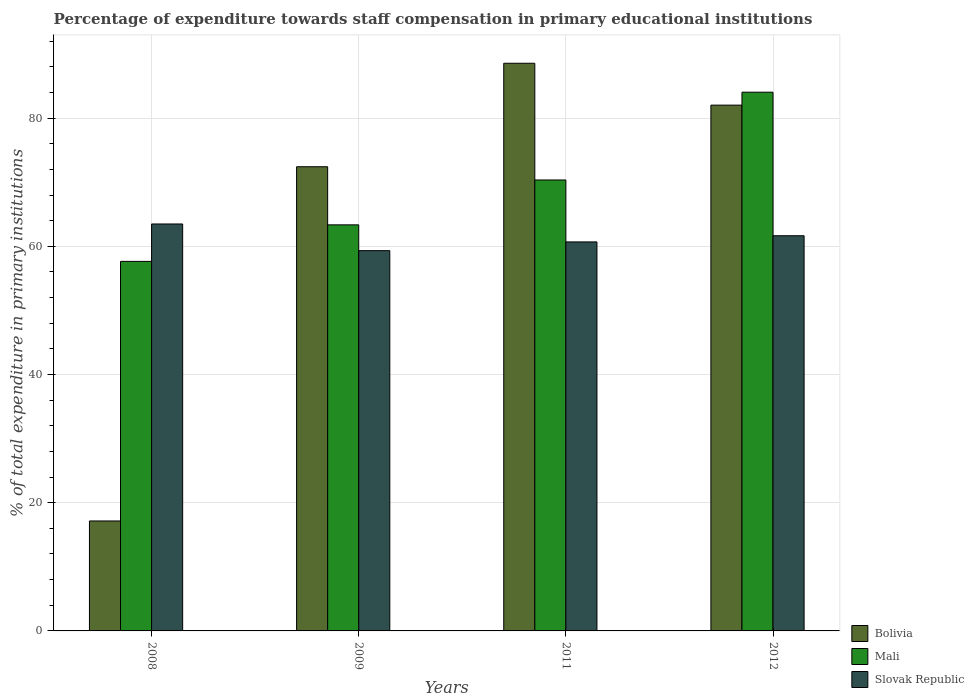How many different coloured bars are there?
Offer a terse response. 3. Are the number of bars per tick equal to the number of legend labels?
Your answer should be very brief. Yes. How many bars are there on the 1st tick from the left?
Keep it short and to the point. 3. What is the label of the 2nd group of bars from the left?
Provide a succinct answer. 2009. In how many cases, is the number of bars for a given year not equal to the number of legend labels?
Ensure brevity in your answer.  0. What is the percentage of expenditure towards staff compensation in Bolivia in 2008?
Your answer should be compact. 17.15. Across all years, what is the maximum percentage of expenditure towards staff compensation in Slovak Republic?
Provide a short and direct response. 63.48. Across all years, what is the minimum percentage of expenditure towards staff compensation in Slovak Republic?
Make the answer very short. 59.32. In which year was the percentage of expenditure towards staff compensation in Mali minimum?
Offer a very short reply. 2008. What is the total percentage of expenditure towards staff compensation in Slovak Republic in the graph?
Keep it short and to the point. 245.14. What is the difference between the percentage of expenditure towards staff compensation in Mali in 2009 and that in 2011?
Make the answer very short. -7. What is the difference between the percentage of expenditure towards staff compensation in Bolivia in 2008 and the percentage of expenditure towards staff compensation in Slovak Republic in 2012?
Keep it short and to the point. -44.49. What is the average percentage of expenditure towards staff compensation in Slovak Republic per year?
Make the answer very short. 61.28. In the year 2009, what is the difference between the percentage of expenditure towards staff compensation in Slovak Republic and percentage of expenditure towards staff compensation in Bolivia?
Provide a succinct answer. -13.09. What is the ratio of the percentage of expenditure towards staff compensation in Mali in 2008 to that in 2012?
Provide a succinct answer. 0.69. Is the percentage of expenditure towards staff compensation in Mali in 2009 less than that in 2012?
Provide a succinct answer. Yes. What is the difference between the highest and the second highest percentage of expenditure towards staff compensation in Bolivia?
Provide a succinct answer. 6.53. What is the difference between the highest and the lowest percentage of expenditure towards staff compensation in Slovak Republic?
Your answer should be very brief. 4.16. Is the sum of the percentage of expenditure towards staff compensation in Slovak Republic in 2009 and 2012 greater than the maximum percentage of expenditure towards staff compensation in Mali across all years?
Keep it short and to the point. Yes. What does the 1st bar from the left in 2008 represents?
Your response must be concise. Bolivia. What does the 3rd bar from the right in 2011 represents?
Ensure brevity in your answer.  Bolivia. How many bars are there?
Your answer should be compact. 12. How many years are there in the graph?
Offer a terse response. 4. Does the graph contain any zero values?
Ensure brevity in your answer.  No. Does the graph contain grids?
Make the answer very short. Yes. How many legend labels are there?
Provide a succinct answer. 3. What is the title of the graph?
Ensure brevity in your answer.  Percentage of expenditure towards staff compensation in primary educational institutions. Does "New Caledonia" appear as one of the legend labels in the graph?
Your answer should be compact. No. What is the label or title of the X-axis?
Provide a short and direct response. Years. What is the label or title of the Y-axis?
Your answer should be compact. % of total expenditure in primary institutions. What is the % of total expenditure in primary institutions of Bolivia in 2008?
Ensure brevity in your answer.  17.15. What is the % of total expenditure in primary institutions in Mali in 2008?
Your answer should be very brief. 57.65. What is the % of total expenditure in primary institutions in Slovak Republic in 2008?
Provide a succinct answer. 63.48. What is the % of total expenditure in primary institutions of Bolivia in 2009?
Give a very brief answer. 72.41. What is the % of total expenditure in primary institutions in Mali in 2009?
Provide a short and direct response. 63.35. What is the % of total expenditure in primary institutions of Slovak Republic in 2009?
Ensure brevity in your answer.  59.32. What is the % of total expenditure in primary institutions of Bolivia in 2011?
Give a very brief answer. 88.55. What is the % of total expenditure in primary institutions of Mali in 2011?
Your answer should be compact. 70.35. What is the % of total expenditure in primary institutions of Slovak Republic in 2011?
Give a very brief answer. 60.68. What is the % of total expenditure in primary institutions of Bolivia in 2012?
Give a very brief answer. 82.02. What is the % of total expenditure in primary institutions of Mali in 2012?
Your answer should be compact. 84.04. What is the % of total expenditure in primary institutions in Slovak Republic in 2012?
Ensure brevity in your answer.  61.65. Across all years, what is the maximum % of total expenditure in primary institutions of Bolivia?
Your answer should be compact. 88.55. Across all years, what is the maximum % of total expenditure in primary institutions of Mali?
Provide a succinct answer. 84.04. Across all years, what is the maximum % of total expenditure in primary institutions of Slovak Republic?
Offer a very short reply. 63.48. Across all years, what is the minimum % of total expenditure in primary institutions in Bolivia?
Keep it short and to the point. 17.15. Across all years, what is the minimum % of total expenditure in primary institutions in Mali?
Offer a very short reply. 57.65. Across all years, what is the minimum % of total expenditure in primary institutions in Slovak Republic?
Provide a short and direct response. 59.32. What is the total % of total expenditure in primary institutions in Bolivia in the graph?
Make the answer very short. 260.14. What is the total % of total expenditure in primary institutions in Mali in the graph?
Offer a very short reply. 275.38. What is the total % of total expenditure in primary institutions in Slovak Republic in the graph?
Make the answer very short. 245.14. What is the difference between the % of total expenditure in primary institutions of Bolivia in 2008 and that in 2009?
Make the answer very short. -55.26. What is the difference between the % of total expenditure in primary institutions of Mali in 2008 and that in 2009?
Your response must be concise. -5.7. What is the difference between the % of total expenditure in primary institutions of Slovak Republic in 2008 and that in 2009?
Your response must be concise. 4.16. What is the difference between the % of total expenditure in primary institutions of Bolivia in 2008 and that in 2011?
Make the answer very short. -71.4. What is the difference between the % of total expenditure in primary institutions of Mali in 2008 and that in 2011?
Provide a succinct answer. -12.7. What is the difference between the % of total expenditure in primary institutions of Slovak Republic in 2008 and that in 2011?
Provide a succinct answer. 2.8. What is the difference between the % of total expenditure in primary institutions of Bolivia in 2008 and that in 2012?
Keep it short and to the point. -64.87. What is the difference between the % of total expenditure in primary institutions in Mali in 2008 and that in 2012?
Offer a terse response. -26.39. What is the difference between the % of total expenditure in primary institutions of Slovak Republic in 2008 and that in 2012?
Provide a short and direct response. 1.83. What is the difference between the % of total expenditure in primary institutions of Bolivia in 2009 and that in 2011?
Your answer should be very brief. -16.14. What is the difference between the % of total expenditure in primary institutions in Mali in 2009 and that in 2011?
Keep it short and to the point. -7. What is the difference between the % of total expenditure in primary institutions in Slovak Republic in 2009 and that in 2011?
Your response must be concise. -1.36. What is the difference between the % of total expenditure in primary institutions of Bolivia in 2009 and that in 2012?
Your answer should be very brief. -9.61. What is the difference between the % of total expenditure in primary institutions in Mali in 2009 and that in 2012?
Give a very brief answer. -20.69. What is the difference between the % of total expenditure in primary institutions of Slovak Republic in 2009 and that in 2012?
Offer a terse response. -2.33. What is the difference between the % of total expenditure in primary institutions of Bolivia in 2011 and that in 2012?
Offer a terse response. 6.53. What is the difference between the % of total expenditure in primary institutions in Mali in 2011 and that in 2012?
Your answer should be compact. -13.69. What is the difference between the % of total expenditure in primary institutions in Slovak Republic in 2011 and that in 2012?
Provide a succinct answer. -0.96. What is the difference between the % of total expenditure in primary institutions of Bolivia in 2008 and the % of total expenditure in primary institutions of Mali in 2009?
Your response must be concise. -46.19. What is the difference between the % of total expenditure in primary institutions in Bolivia in 2008 and the % of total expenditure in primary institutions in Slovak Republic in 2009?
Provide a short and direct response. -42.17. What is the difference between the % of total expenditure in primary institutions in Mali in 2008 and the % of total expenditure in primary institutions in Slovak Republic in 2009?
Your response must be concise. -1.67. What is the difference between the % of total expenditure in primary institutions in Bolivia in 2008 and the % of total expenditure in primary institutions in Mali in 2011?
Offer a very short reply. -53.19. What is the difference between the % of total expenditure in primary institutions of Bolivia in 2008 and the % of total expenditure in primary institutions of Slovak Republic in 2011?
Your response must be concise. -43.53. What is the difference between the % of total expenditure in primary institutions of Mali in 2008 and the % of total expenditure in primary institutions of Slovak Republic in 2011?
Keep it short and to the point. -3.04. What is the difference between the % of total expenditure in primary institutions of Bolivia in 2008 and the % of total expenditure in primary institutions of Mali in 2012?
Provide a succinct answer. -66.89. What is the difference between the % of total expenditure in primary institutions of Bolivia in 2008 and the % of total expenditure in primary institutions of Slovak Republic in 2012?
Provide a short and direct response. -44.49. What is the difference between the % of total expenditure in primary institutions of Mali in 2008 and the % of total expenditure in primary institutions of Slovak Republic in 2012?
Provide a short and direct response. -4. What is the difference between the % of total expenditure in primary institutions of Bolivia in 2009 and the % of total expenditure in primary institutions of Mali in 2011?
Your answer should be very brief. 2.06. What is the difference between the % of total expenditure in primary institutions in Bolivia in 2009 and the % of total expenditure in primary institutions in Slovak Republic in 2011?
Make the answer very short. 11.73. What is the difference between the % of total expenditure in primary institutions of Mali in 2009 and the % of total expenditure in primary institutions of Slovak Republic in 2011?
Your answer should be compact. 2.66. What is the difference between the % of total expenditure in primary institutions of Bolivia in 2009 and the % of total expenditure in primary institutions of Mali in 2012?
Give a very brief answer. -11.63. What is the difference between the % of total expenditure in primary institutions in Bolivia in 2009 and the % of total expenditure in primary institutions in Slovak Republic in 2012?
Your answer should be compact. 10.76. What is the difference between the % of total expenditure in primary institutions in Mali in 2009 and the % of total expenditure in primary institutions in Slovak Republic in 2012?
Your answer should be very brief. 1.7. What is the difference between the % of total expenditure in primary institutions of Bolivia in 2011 and the % of total expenditure in primary institutions of Mali in 2012?
Your response must be concise. 4.51. What is the difference between the % of total expenditure in primary institutions of Bolivia in 2011 and the % of total expenditure in primary institutions of Slovak Republic in 2012?
Your answer should be compact. 26.91. What is the difference between the % of total expenditure in primary institutions in Mali in 2011 and the % of total expenditure in primary institutions in Slovak Republic in 2012?
Offer a very short reply. 8.7. What is the average % of total expenditure in primary institutions of Bolivia per year?
Your answer should be very brief. 65.04. What is the average % of total expenditure in primary institutions in Mali per year?
Your response must be concise. 68.85. What is the average % of total expenditure in primary institutions of Slovak Republic per year?
Your answer should be compact. 61.28. In the year 2008, what is the difference between the % of total expenditure in primary institutions in Bolivia and % of total expenditure in primary institutions in Mali?
Provide a succinct answer. -40.49. In the year 2008, what is the difference between the % of total expenditure in primary institutions of Bolivia and % of total expenditure in primary institutions of Slovak Republic?
Your answer should be compact. -46.33. In the year 2008, what is the difference between the % of total expenditure in primary institutions in Mali and % of total expenditure in primary institutions in Slovak Republic?
Your answer should be very brief. -5.83. In the year 2009, what is the difference between the % of total expenditure in primary institutions of Bolivia and % of total expenditure in primary institutions of Mali?
Keep it short and to the point. 9.06. In the year 2009, what is the difference between the % of total expenditure in primary institutions in Bolivia and % of total expenditure in primary institutions in Slovak Republic?
Offer a very short reply. 13.09. In the year 2009, what is the difference between the % of total expenditure in primary institutions in Mali and % of total expenditure in primary institutions in Slovak Republic?
Give a very brief answer. 4.02. In the year 2011, what is the difference between the % of total expenditure in primary institutions in Bolivia and % of total expenditure in primary institutions in Mali?
Offer a terse response. 18.21. In the year 2011, what is the difference between the % of total expenditure in primary institutions in Bolivia and % of total expenditure in primary institutions in Slovak Republic?
Keep it short and to the point. 27.87. In the year 2011, what is the difference between the % of total expenditure in primary institutions of Mali and % of total expenditure in primary institutions of Slovak Republic?
Offer a very short reply. 9.66. In the year 2012, what is the difference between the % of total expenditure in primary institutions of Bolivia and % of total expenditure in primary institutions of Mali?
Ensure brevity in your answer.  -2.02. In the year 2012, what is the difference between the % of total expenditure in primary institutions in Bolivia and % of total expenditure in primary institutions in Slovak Republic?
Offer a very short reply. 20.37. In the year 2012, what is the difference between the % of total expenditure in primary institutions of Mali and % of total expenditure in primary institutions of Slovak Republic?
Provide a succinct answer. 22.39. What is the ratio of the % of total expenditure in primary institutions of Bolivia in 2008 to that in 2009?
Provide a short and direct response. 0.24. What is the ratio of the % of total expenditure in primary institutions of Mali in 2008 to that in 2009?
Offer a very short reply. 0.91. What is the ratio of the % of total expenditure in primary institutions in Slovak Republic in 2008 to that in 2009?
Provide a short and direct response. 1.07. What is the ratio of the % of total expenditure in primary institutions of Bolivia in 2008 to that in 2011?
Your response must be concise. 0.19. What is the ratio of the % of total expenditure in primary institutions in Mali in 2008 to that in 2011?
Offer a terse response. 0.82. What is the ratio of the % of total expenditure in primary institutions in Slovak Republic in 2008 to that in 2011?
Your answer should be very brief. 1.05. What is the ratio of the % of total expenditure in primary institutions of Bolivia in 2008 to that in 2012?
Your response must be concise. 0.21. What is the ratio of the % of total expenditure in primary institutions in Mali in 2008 to that in 2012?
Offer a terse response. 0.69. What is the ratio of the % of total expenditure in primary institutions in Slovak Republic in 2008 to that in 2012?
Your answer should be compact. 1.03. What is the ratio of the % of total expenditure in primary institutions in Bolivia in 2009 to that in 2011?
Provide a succinct answer. 0.82. What is the ratio of the % of total expenditure in primary institutions of Mali in 2009 to that in 2011?
Ensure brevity in your answer.  0.9. What is the ratio of the % of total expenditure in primary institutions in Slovak Republic in 2009 to that in 2011?
Give a very brief answer. 0.98. What is the ratio of the % of total expenditure in primary institutions in Bolivia in 2009 to that in 2012?
Provide a succinct answer. 0.88. What is the ratio of the % of total expenditure in primary institutions in Mali in 2009 to that in 2012?
Offer a very short reply. 0.75. What is the ratio of the % of total expenditure in primary institutions of Slovak Republic in 2009 to that in 2012?
Your response must be concise. 0.96. What is the ratio of the % of total expenditure in primary institutions of Bolivia in 2011 to that in 2012?
Provide a short and direct response. 1.08. What is the ratio of the % of total expenditure in primary institutions in Mali in 2011 to that in 2012?
Your answer should be very brief. 0.84. What is the ratio of the % of total expenditure in primary institutions of Slovak Republic in 2011 to that in 2012?
Your answer should be compact. 0.98. What is the difference between the highest and the second highest % of total expenditure in primary institutions in Bolivia?
Your answer should be very brief. 6.53. What is the difference between the highest and the second highest % of total expenditure in primary institutions in Mali?
Keep it short and to the point. 13.69. What is the difference between the highest and the second highest % of total expenditure in primary institutions in Slovak Republic?
Provide a short and direct response. 1.83. What is the difference between the highest and the lowest % of total expenditure in primary institutions of Bolivia?
Provide a succinct answer. 71.4. What is the difference between the highest and the lowest % of total expenditure in primary institutions in Mali?
Your answer should be very brief. 26.39. What is the difference between the highest and the lowest % of total expenditure in primary institutions in Slovak Republic?
Offer a very short reply. 4.16. 